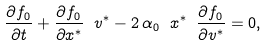<formula> <loc_0><loc_0><loc_500><loc_500>\frac { \partial f _ { 0 } } { \partial t } + \frac { \partial f _ { 0 } } { \partial x ^ { * } } \ v ^ { * } - 2 \, \alpha _ { 0 } \ x ^ { * } \ \frac { \partial f _ { 0 } } { \partial v ^ { * } } = 0 ,</formula> 